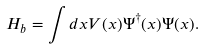<formula> <loc_0><loc_0><loc_500><loc_500>H _ { b } = \int d x V ( x ) \Psi ^ { \dagger } ( x ) \Psi ( x ) .</formula> 